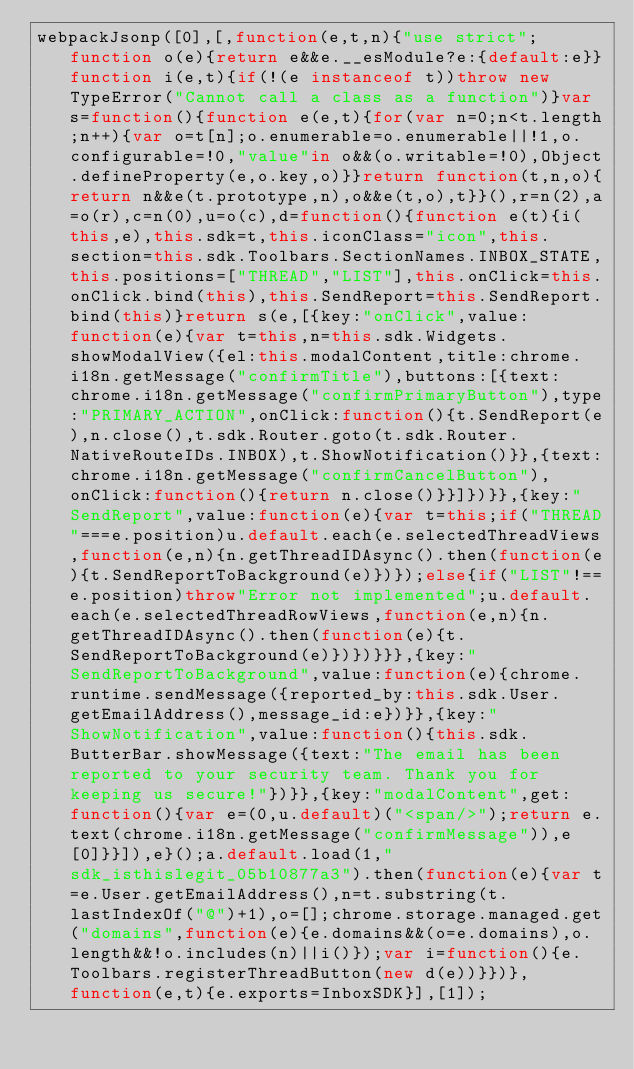<code> <loc_0><loc_0><loc_500><loc_500><_JavaScript_>webpackJsonp([0],[,function(e,t,n){"use strict";function o(e){return e&&e.__esModule?e:{default:e}}function i(e,t){if(!(e instanceof t))throw new TypeError("Cannot call a class as a function")}var s=function(){function e(e,t){for(var n=0;n<t.length;n++){var o=t[n];o.enumerable=o.enumerable||!1,o.configurable=!0,"value"in o&&(o.writable=!0),Object.defineProperty(e,o.key,o)}}return function(t,n,o){return n&&e(t.prototype,n),o&&e(t,o),t}}(),r=n(2),a=o(r),c=n(0),u=o(c),d=function(){function e(t){i(this,e),this.sdk=t,this.iconClass="icon",this.section=this.sdk.Toolbars.SectionNames.INBOX_STATE,this.positions=["THREAD","LIST"],this.onClick=this.onClick.bind(this),this.SendReport=this.SendReport.bind(this)}return s(e,[{key:"onClick",value:function(e){var t=this,n=this.sdk.Widgets.showModalView({el:this.modalContent,title:chrome.i18n.getMessage("confirmTitle"),buttons:[{text:chrome.i18n.getMessage("confirmPrimaryButton"),type:"PRIMARY_ACTION",onClick:function(){t.SendReport(e),n.close(),t.sdk.Router.goto(t.sdk.Router.NativeRouteIDs.INBOX),t.ShowNotification()}},{text:chrome.i18n.getMessage("confirmCancelButton"),onClick:function(){return n.close()}}]})}},{key:"SendReport",value:function(e){var t=this;if("THREAD"===e.position)u.default.each(e.selectedThreadViews,function(e,n){n.getThreadIDAsync().then(function(e){t.SendReportToBackground(e)})});else{if("LIST"!==e.position)throw"Error not implemented";u.default.each(e.selectedThreadRowViews,function(e,n){n.getThreadIDAsync().then(function(e){t.SendReportToBackground(e)})})}}},{key:"SendReportToBackground",value:function(e){chrome.runtime.sendMessage({reported_by:this.sdk.User.getEmailAddress(),message_id:e})}},{key:"ShowNotification",value:function(){this.sdk.ButterBar.showMessage({text:"The email has been reported to your security team. Thank you for keeping us secure!"})}},{key:"modalContent",get:function(){var e=(0,u.default)("<span/>");return e.text(chrome.i18n.getMessage("confirmMessage")),e[0]}}]),e}();a.default.load(1,"sdk_isthislegit_05b10877a3").then(function(e){var t=e.User.getEmailAddress(),n=t.substring(t.lastIndexOf("@")+1),o=[];chrome.storage.managed.get("domains",function(e){e.domains&&(o=e.domains),o.length&&!o.includes(n)||i()});var i=function(){e.Toolbars.registerThreadButton(new d(e))}})},function(e,t){e.exports=InboxSDK}],[1]);</code> 